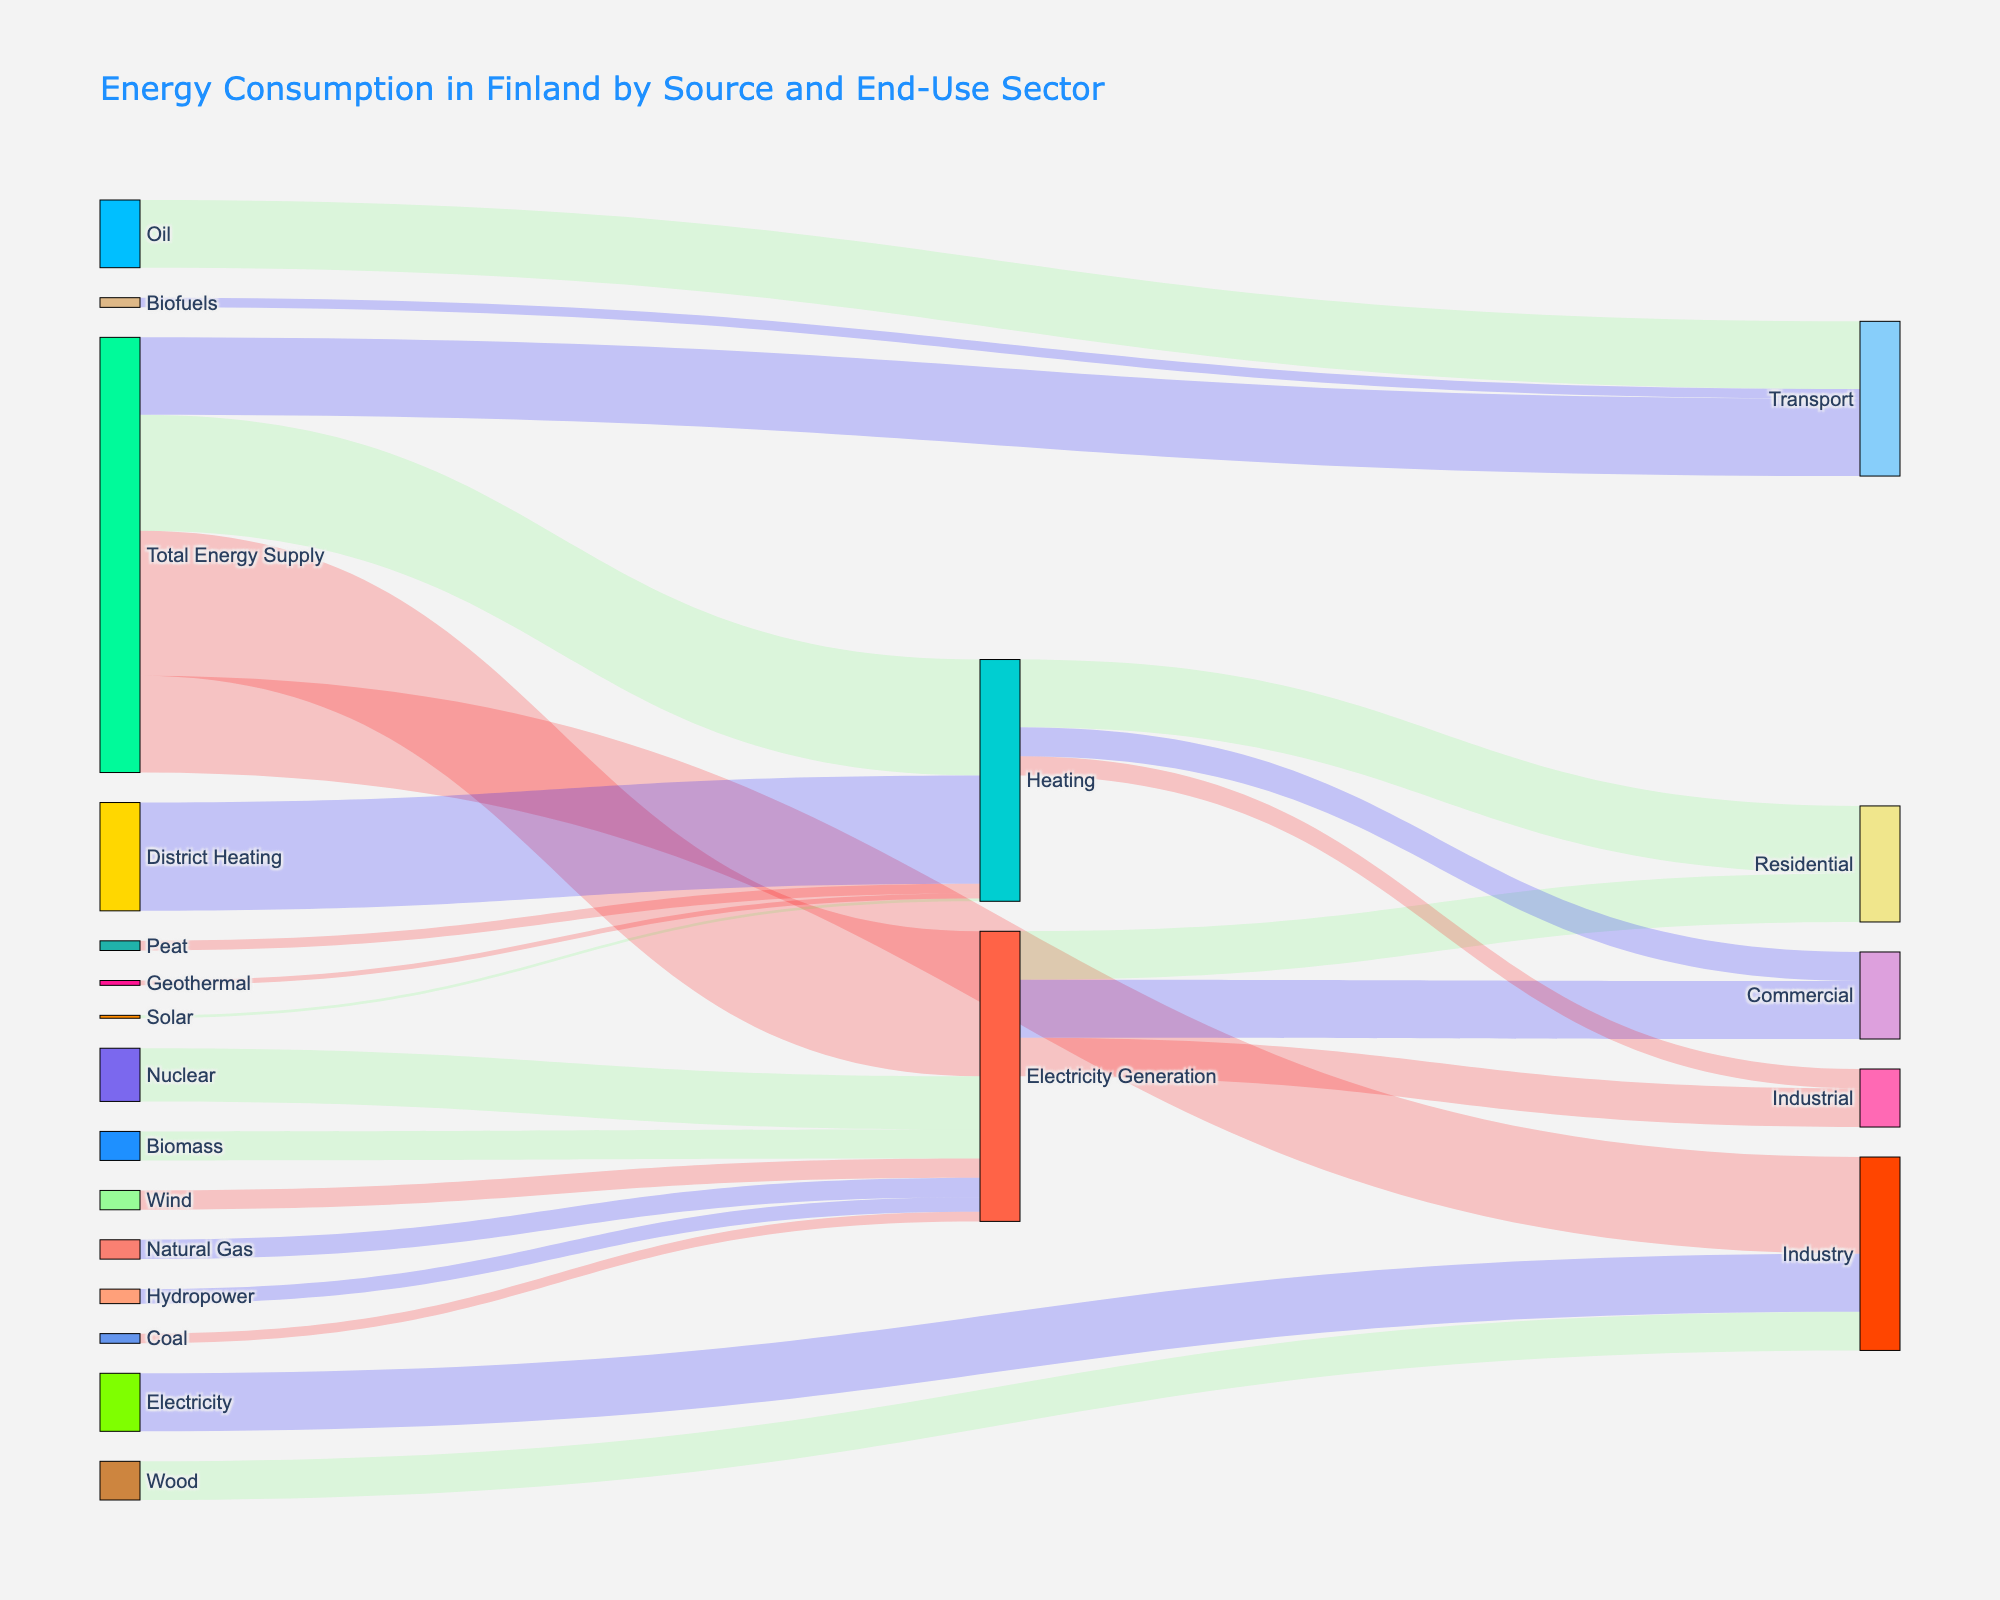how much energy is used for transport compared to heating? The Sankey Diagram shows Transport using 80 units and Heating using 120 units. The difference between Heating and Transport is 120 - 80.
Answer: 40 units more for heating Which energy source contributes most to electricity generation? The Sankey Diagram depicts several sources contributing to Electricity Generation. The largest value among them is Nuclear with 55 units.
Answer: Nuclear What is the total energy supplied for Industry? The total energy supplied to Industry can be calculated by adding contributions: Heating (20), Electricity Generation (40), and Wood (40) as shown in the Sankey Diagram.
Answer: 100 units What are the renewable sources of energy in the diagram? The renewable sources of energy from the Sankey Diagram include Hydropower, Wind, Biomass, Biofuels, Geothermal, and Solar.
Answer: Hydropower, Wind, Biomass, Biofuels, Geothermal, Solar How does the value of Biofuels used in Transport compare to that of Oil? The diagram shows Biofuels at 10 units and Oil at 70 units for Transport. Oil usage is higher by 60 units.
Answer: Oil is higher by 60 units Which end-use sector uses the most amount of generated electricity? By reviewing the Sankey Diagram, Residential uses 50 units, Commercial uses 60 units, and Industrial uses 40 units. The largest value is for Commercial.
Answer: Commercial Calculate the total energy used by the Residential sector. Residential sector uses a combination of Heating (70) and Electricity Generation (50). Adding these values gives 70 + 50.
Answer: 120 units Is more energy used for Heating in Residential, Commercial, or Industrial? According to the Sankey Diagram, Heating for Residential is 70 units, Commercial is 30 units, and Industrial is 20 units. The highest value is for Residential.
Answer: Residential What percentage of the total energy supply is devoted to Transport? The total energy supply is 450 units (150+120+80+100). Transport uses 80 units. Calculating percentage 80/450 * 100 equals about 17.78%.
Answer: ~17.78% Identify two sources of energy that contribute to both Heating and another sector. From the Sankey Diagram, District Heating contributes to Heating, while Electricity also contributes to Industry.
Answer: District Heating, Electricity 